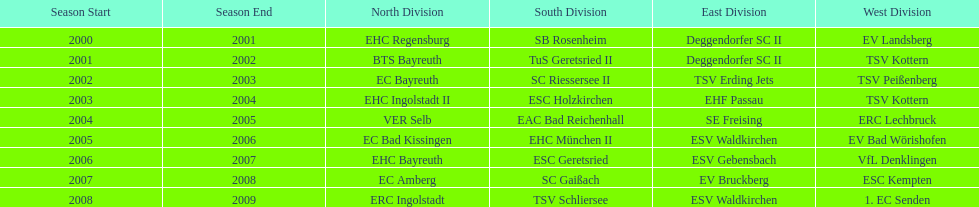Which name appears more often, kottern or bayreuth? Bayreuth. 